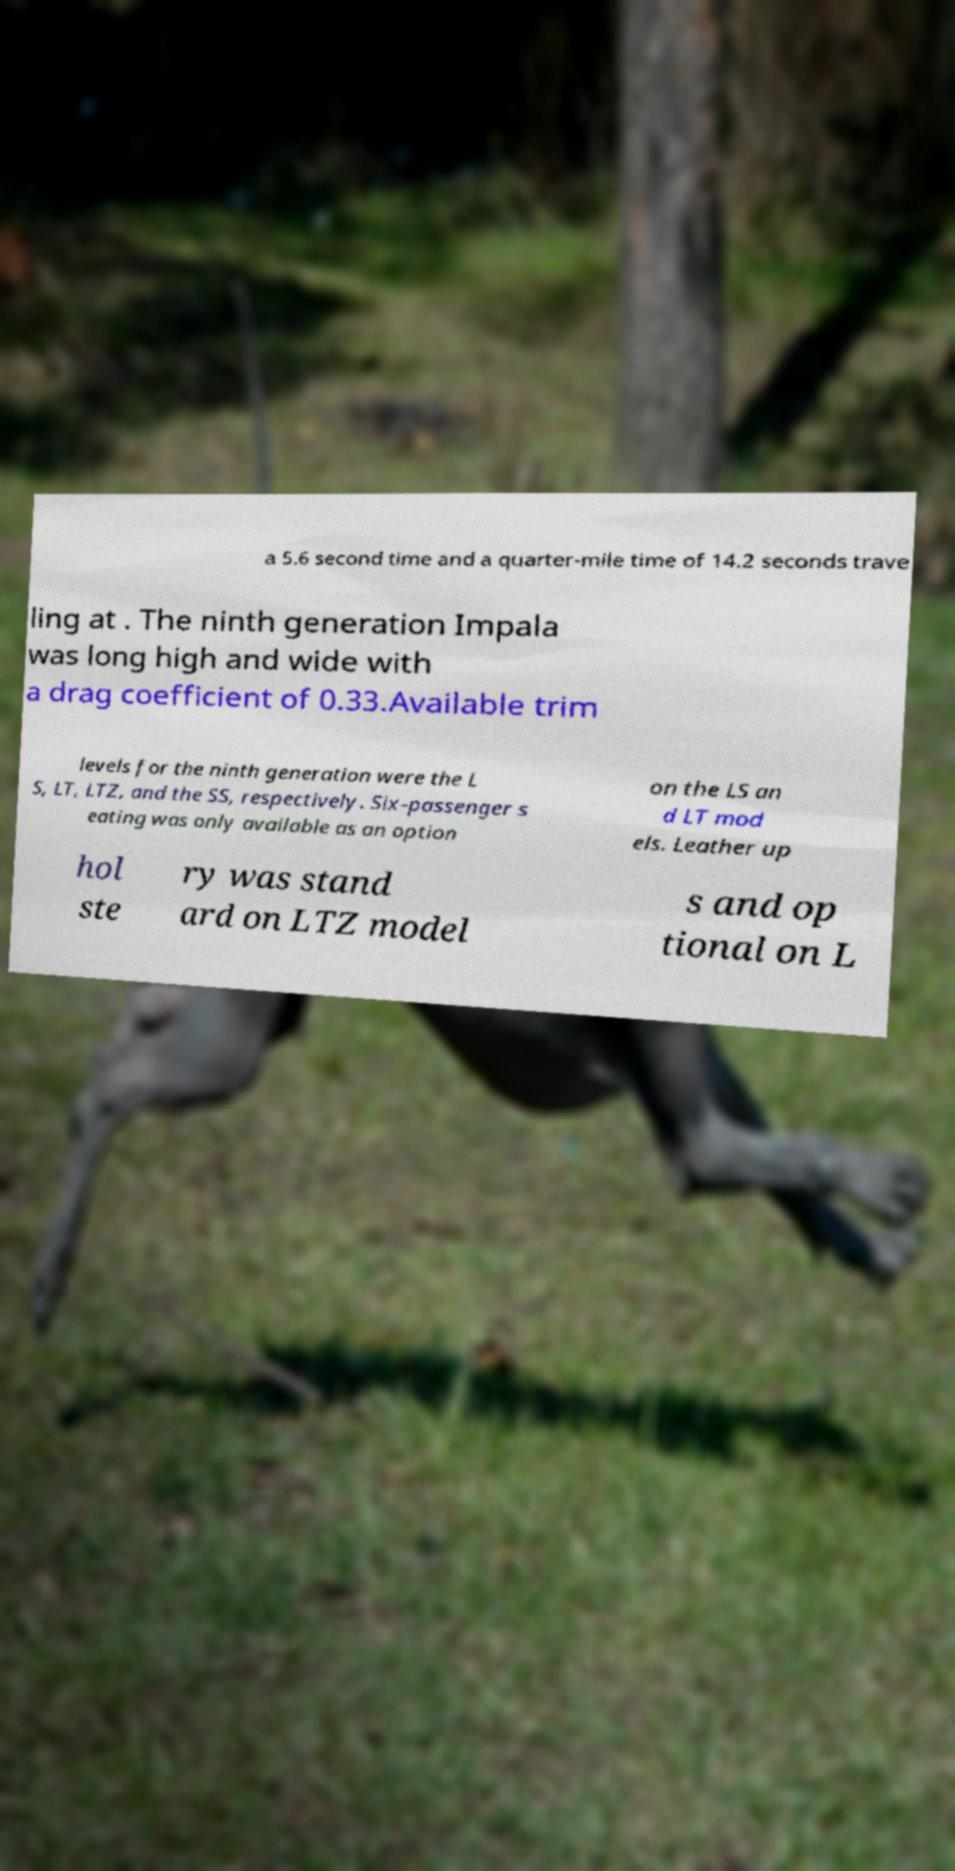I need the written content from this picture converted into text. Can you do that? a 5.6 second time and a quarter-mile time of 14.2 seconds trave ling at . The ninth generation Impala was long high and wide with a drag coefficient of 0.33.Available trim levels for the ninth generation were the L S, LT, LTZ, and the SS, respectively. Six-passenger s eating was only available as an option on the LS an d LT mod els. Leather up hol ste ry was stand ard on LTZ model s and op tional on L 